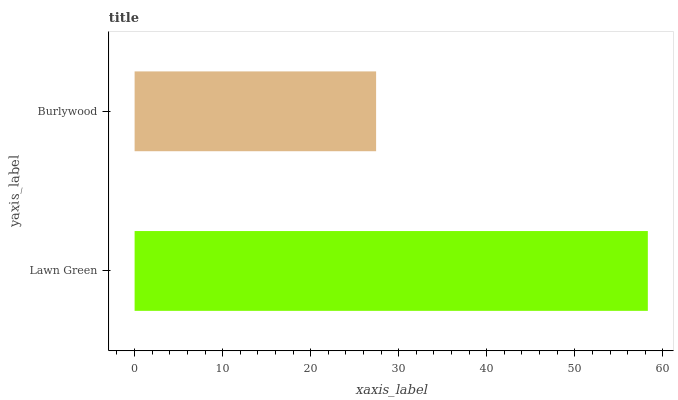Is Burlywood the minimum?
Answer yes or no. Yes. Is Lawn Green the maximum?
Answer yes or no. Yes. Is Burlywood the maximum?
Answer yes or no. No. Is Lawn Green greater than Burlywood?
Answer yes or no. Yes. Is Burlywood less than Lawn Green?
Answer yes or no. Yes. Is Burlywood greater than Lawn Green?
Answer yes or no. No. Is Lawn Green less than Burlywood?
Answer yes or no. No. Is Lawn Green the high median?
Answer yes or no. Yes. Is Burlywood the low median?
Answer yes or no. Yes. Is Burlywood the high median?
Answer yes or no. No. Is Lawn Green the low median?
Answer yes or no. No. 